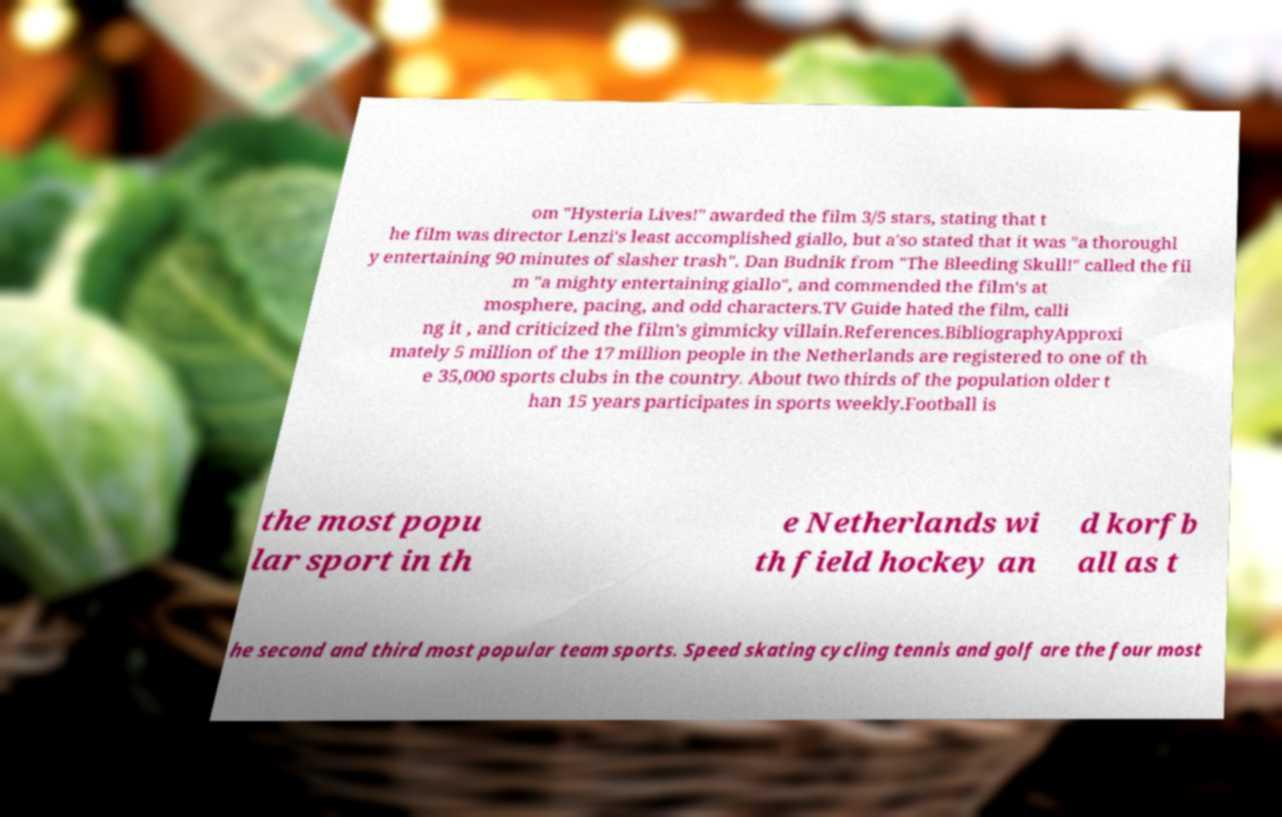Can you read and provide the text displayed in the image?This photo seems to have some interesting text. Can you extract and type it out for me? om "Hysteria Lives!" awarded the film 3/5 stars, stating that t he film was director Lenzi's least accomplished giallo, but a'so stated that it was "a thoroughl y entertaining 90 minutes of slasher trash". Dan Budnik from "The Bleeding Skull!" called the fil m "a mighty entertaining giallo", and commended the film's at mosphere, pacing, and odd characters.TV Guide hated the film, calli ng it , and criticized the film's gimmicky villain.References.BibliographyApproxi mately 5 million of the 17 million people in the Netherlands are registered to one of th e 35,000 sports clubs in the country. About two thirds of the population older t han 15 years participates in sports weekly.Football is the most popu lar sport in th e Netherlands wi th field hockey an d korfb all as t he second and third most popular team sports. Speed skating cycling tennis and golf are the four most 